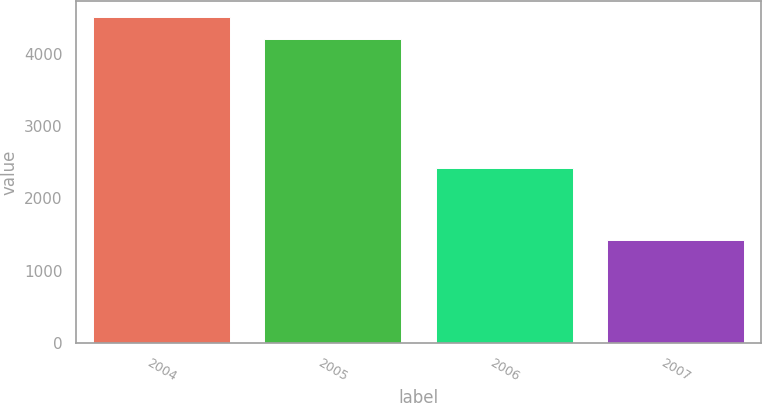<chart> <loc_0><loc_0><loc_500><loc_500><bar_chart><fcel>2004<fcel>2005<fcel>2006<fcel>2007<nl><fcel>4509<fcel>4217<fcel>2427<fcel>1425<nl></chart> 